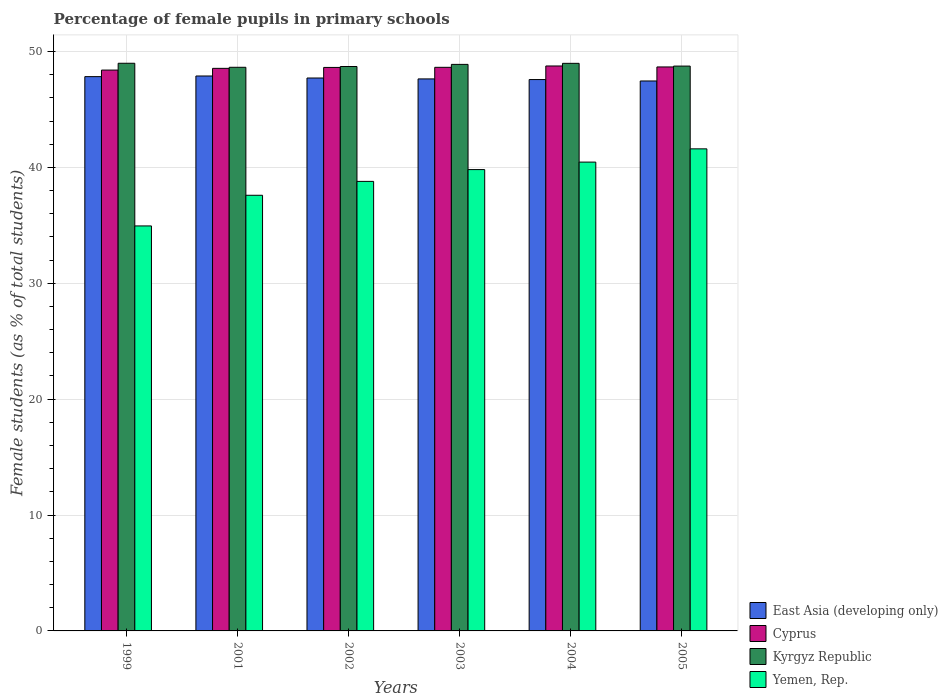How many different coloured bars are there?
Make the answer very short. 4. How many groups of bars are there?
Your answer should be compact. 6. How many bars are there on the 6th tick from the left?
Your answer should be very brief. 4. How many bars are there on the 2nd tick from the right?
Give a very brief answer. 4. What is the label of the 1st group of bars from the left?
Make the answer very short. 1999. What is the percentage of female pupils in primary schools in Yemen, Rep. in 2004?
Provide a succinct answer. 40.45. Across all years, what is the maximum percentage of female pupils in primary schools in Yemen, Rep.?
Provide a succinct answer. 41.6. Across all years, what is the minimum percentage of female pupils in primary schools in Cyprus?
Make the answer very short. 48.4. In which year was the percentage of female pupils in primary schools in Cyprus maximum?
Your answer should be very brief. 2004. In which year was the percentage of female pupils in primary schools in East Asia (developing only) minimum?
Provide a short and direct response. 2005. What is the total percentage of female pupils in primary schools in Cyprus in the graph?
Make the answer very short. 291.62. What is the difference between the percentage of female pupils in primary schools in Yemen, Rep. in 1999 and that in 2005?
Ensure brevity in your answer.  -6.65. What is the difference between the percentage of female pupils in primary schools in Yemen, Rep. in 2003 and the percentage of female pupils in primary schools in East Asia (developing only) in 1999?
Make the answer very short. -8.02. What is the average percentage of female pupils in primary schools in East Asia (developing only) per year?
Your answer should be compact. 47.68. In the year 2003, what is the difference between the percentage of female pupils in primary schools in Cyprus and percentage of female pupils in primary schools in Yemen, Rep.?
Give a very brief answer. 8.82. What is the ratio of the percentage of female pupils in primary schools in Kyrgyz Republic in 2003 to that in 2004?
Give a very brief answer. 1. Is the percentage of female pupils in primary schools in East Asia (developing only) in 1999 less than that in 2003?
Provide a short and direct response. No. What is the difference between the highest and the second highest percentage of female pupils in primary schools in East Asia (developing only)?
Your answer should be compact. 0.05. What is the difference between the highest and the lowest percentage of female pupils in primary schools in East Asia (developing only)?
Your answer should be very brief. 0.43. In how many years, is the percentage of female pupils in primary schools in Cyprus greater than the average percentage of female pupils in primary schools in Cyprus taken over all years?
Offer a very short reply. 4. Is the sum of the percentage of female pupils in primary schools in Kyrgyz Republic in 1999 and 2003 greater than the maximum percentage of female pupils in primary schools in Cyprus across all years?
Keep it short and to the point. Yes. What does the 1st bar from the left in 1999 represents?
Keep it short and to the point. East Asia (developing only). What does the 4th bar from the right in 2003 represents?
Provide a short and direct response. East Asia (developing only). Is it the case that in every year, the sum of the percentage of female pupils in primary schools in East Asia (developing only) and percentage of female pupils in primary schools in Yemen, Rep. is greater than the percentage of female pupils in primary schools in Cyprus?
Your response must be concise. Yes. What is the difference between two consecutive major ticks on the Y-axis?
Give a very brief answer. 10. How many legend labels are there?
Your answer should be compact. 4. How are the legend labels stacked?
Make the answer very short. Vertical. What is the title of the graph?
Offer a terse response. Percentage of female pupils in primary schools. Does "Niger" appear as one of the legend labels in the graph?
Offer a terse response. No. What is the label or title of the Y-axis?
Provide a succinct answer. Female students (as % of total students). What is the Female students (as % of total students) in East Asia (developing only) in 1999?
Provide a succinct answer. 47.83. What is the Female students (as % of total students) of Cyprus in 1999?
Your answer should be very brief. 48.4. What is the Female students (as % of total students) of Kyrgyz Republic in 1999?
Offer a very short reply. 48.98. What is the Female students (as % of total students) in Yemen, Rep. in 1999?
Your answer should be very brief. 34.95. What is the Female students (as % of total students) in East Asia (developing only) in 2001?
Ensure brevity in your answer.  47.89. What is the Female students (as % of total students) in Cyprus in 2001?
Your response must be concise. 48.55. What is the Female students (as % of total students) of Kyrgyz Republic in 2001?
Offer a very short reply. 48.64. What is the Female students (as % of total students) in Yemen, Rep. in 2001?
Offer a terse response. 37.59. What is the Female students (as % of total students) in East Asia (developing only) in 2002?
Your answer should be very brief. 47.71. What is the Female students (as % of total students) of Cyprus in 2002?
Give a very brief answer. 48.62. What is the Female students (as % of total students) of Kyrgyz Republic in 2002?
Give a very brief answer. 48.7. What is the Female students (as % of total students) of Yemen, Rep. in 2002?
Make the answer very short. 38.79. What is the Female students (as % of total students) in East Asia (developing only) in 2003?
Offer a terse response. 47.63. What is the Female students (as % of total students) of Cyprus in 2003?
Provide a short and direct response. 48.63. What is the Female students (as % of total students) of Kyrgyz Republic in 2003?
Your answer should be compact. 48.89. What is the Female students (as % of total students) of Yemen, Rep. in 2003?
Give a very brief answer. 39.81. What is the Female students (as % of total students) in East Asia (developing only) in 2004?
Make the answer very short. 47.58. What is the Female students (as % of total students) in Cyprus in 2004?
Provide a short and direct response. 48.75. What is the Female students (as % of total students) in Kyrgyz Republic in 2004?
Provide a succinct answer. 48.98. What is the Female students (as % of total students) of Yemen, Rep. in 2004?
Provide a succinct answer. 40.45. What is the Female students (as % of total students) in East Asia (developing only) in 2005?
Your response must be concise. 47.46. What is the Female students (as % of total students) in Cyprus in 2005?
Offer a very short reply. 48.67. What is the Female students (as % of total students) of Kyrgyz Republic in 2005?
Your answer should be compact. 48.74. What is the Female students (as % of total students) of Yemen, Rep. in 2005?
Your answer should be compact. 41.6. Across all years, what is the maximum Female students (as % of total students) of East Asia (developing only)?
Your response must be concise. 47.89. Across all years, what is the maximum Female students (as % of total students) in Cyprus?
Provide a succinct answer. 48.75. Across all years, what is the maximum Female students (as % of total students) in Kyrgyz Republic?
Offer a terse response. 48.98. Across all years, what is the maximum Female students (as % of total students) in Yemen, Rep.?
Give a very brief answer. 41.6. Across all years, what is the minimum Female students (as % of total students) of East Asia (developing only)?
Make the answer very short. 47.46. Across all years, what is the minimum Female students (as % of total students) of Cyprus?
Provide a short and direct response. 48.4. Across all years, what is the minimum Female students (as % of total students) of Kyrgyz Republic?
Your response must be concise. 48.64. Across all years, what is the minimum Female students (as % of total students) of Yemen, Rep.?
Your response must be concise. 34.95. What is the total Female students (as % of total students) in East Asia (developing only) in the graph?
Your answer should be compact. 286.1. What is the total Female students (as % of total students) in Cyprus in the graph?
Give a very brief answer. 291.62. What is the total Female students (as % of total students) of Kyrgyz Republic in the graph?
Give a very brief answer. 292.93. What is the total Female students (as % of total students) of Yemen, Rep. in the graph?
Provide a short and direct response. 233.2. What is the difference between the Female students (as % of total students) in East Asia (developing only) in 1999 and that in 2001?
Offer a very short reply. -0.05. What is the difference between the Female students (as % of total students) in Cyprus in 1999 and that in 2001?
Give a very brief answer. -0.15. What is the difference between the Female students (as % of total students) in Kyrgyz Republic in 1999 and that in 2001?
Your response must be concise. 0.35. What is the difference between the Female students (as % of total students) in Yemen, Rep. in 1999 and that in 2001?
Ensure brevity in your answer.  -2.65. What is the difference between the Female students (as % of total students) of East Asia (developing only) in 1999 and that in 2002?
Give a very brief answer. 0.12. What is the difference between the Female students (as % of total students) in Cyprus in 1999 and that in 2002?
Provide a short and direct response. -0.23. What is the difference between the Female students (as % of total students) of Kyrgyz Republic in 1999 and that in 2002?
Ensure brevity in your answer.  0.28. What is the difference between the Female students (as % of total students) of Yemen, Rep. in 1999 and that in 2002?
Make the answer very short. -3.84. What is the difference between the Female students (as % of total students) of East Asia (developing only) in 1999 and that in 2003?
Offer a very short reply. 0.2. What is the difference between the Female students (as % of total students) of Cyprus in 1999 and that in 2003?
Provide a succinct answer. -0.24. What is the difference between the Female students (as % of total students) of Kyrgyz Republic in 1999 and that in 2003?
Your answer should be compact. 0.1. What is the difference between the Female students (as % of total students) in Yemen, Rep. in 1999 and that in 2003?
Make the answer very short. -4.86. What is the difference between the Female students (as % of total students) in East Asia (developing only) in 1999 and that in 2004?
Offer a very short reply. 0.25. What is the difference between the Female students (as % of total students) in Cyprus in 1999 and that in 2004?
Give a very brief answer. -0.35. What is the difference between the Female students (as % of total students) in Kyrgyz Republic in 1999 and that in 2004?
Provide a short and direct response. 0.01. What is the difference between the Female students (as % of total students) in Yemen, Rep. in 1999 and that in 2004?
Your response must be concise. -5.51. What is the difference between the Female students (as % of total students) of East Asia (developing only) in 1999 and that in 2005?
Keep it short and to the point. 0.38. What is the difference between the Female students (as % of total students) of Cyprus in 1999 and that in 2005?
Ensure brevity in your answer.  -0.27. What is the difference between the Female students (as % of total students) in Kyrgyz Republic in 1999 and that in 2005?
Provide a succinct answer. 0.24. What is the difference between the Female students (as % of total students) in Yemen, Rep. in 1999 and that in 2005?
Offer a very short reply. -6.65. What is the difference between the Female students (as % of total students) of East Asia (developing only) in 2001 and that in 2002?
Your answer should be compact. 0.17. What is the difference between the Female students (as % of total students) of Cyprus in 2001 and that in 2002?
Offer a very short reply. -0.08. What is the difference between the Female students (as % of total students) in Kyrgyz Republic in 2001 and that in 2002?
Make the answer very short. -0.07. What is the difference between the Female students (as % of total students) in Yemen, Rep. in 2001 and that in 2002?
Provide a succinct answer. -1.2. What is the difference between the Female students (as % of total students) in East Asia (developing only) in 2001 and that in 2003?
Ensure brevity in your answer.  0.25. What is the difference between the Female students (as % of total students) in Cyprus in 2001 and that in 2003?
Keep it short and to the point. -0.09. What is the difference between the Female students (as % of total students) in Kyrgyz Republic in 2001 and that in 2003?
Keep it short and to the point. -0.25. What is the difference between the Female students (as % of total students) of Yemen, Rep. in 2001 and that in 2003?
Keep it short and to the point. -2.22. What is the difference between the Female students (as % of total students) in East Asia (developing only) in 2001 and that in 2004?
Your answer should be very brief. 0.31. What is the difference between the Female students (as % of total students) of Cyprus in 2001 and that in 2004?
Provide a succinct answer. -0.2. What is the difference between the Female students (as % of total students) in Kyrgyz Republic in 2001 and that in 2004?
Give a very brief answer. -0.34. What is the difference between the Female students (as % of total students) of Yemen, Rep. in 2001 and that in 2004?
Provide a succinct answer. -2.86. What is the difference between the Female students (as % of total students) of East Asia (developing only) in 2001 and that in 2005?
Provide a short and direct response. 0.43. What is the difference between the Female students (as % of total students) of Cyprus in 2001 and that in 2005?
Make the answer very short. -0.12. What is the difference between the Female students (as % of total students) in Kyrgyz Republic in 2001 and that in 2005?
Your answer should be very brief. -0.1. What is the difference between the Female students (as % of total students) of Yemen, Rep. in 2001 and that in 2005?
Give a very brief answer. -4.01. What is the difference between the Female students (as % of total students) in East Asia (developing only) in 2002 and that in 2003?
Your answer should be very brief. 0.08. What is the difference between the Female students (as % of total students) of Cyprus in 2002 and that in 2003?
Your response must be concise. -0.01. What is the difference between the Female students (as % of total students) of Kyrgyz Republic in 2002 and that in 2003?
Offer a terse response. -0.18. What is the difference between the Female students (as % of total students) of Yemen, Rep. in 2002 and that in 2003?
Provide a succinct answer. -1.02. What is the difference between the Female students (as % of total students) of East Asia (developing only) in 2002 and that in 2004?
Make the answer very short. 0.13. What is the difference between the Female students (as % of total students) of Cyprus in 2002 and that in 2004?
Your response must be concise. -0.13. What is the difference between the Female students (as % of total students) in Kyrgyz Republic in 2002 and that in 2004?
Provide a short and direct response. -0.27. What is the difference between the Female students (as % of total students) in Yemen, Rep. in 2002 and that in 2004?
Offer a terse response. -1.66. What is the difference between the Female students (as % of total students) of East Asia (developing only) in 2002 and that in 2005?
Keep it short and to the point. 0.26. What is the difference between the Female students (as % of total students) of Cyprus in 2002 and that in 2005?
Keep it short and to the point. -0.04. What is the difference between the Female students (as % of total students) in Kyrgyz Republic in 2002 and that in 2005?
Make the answer very short. -0.04. What is the difference between the Female students (as % of total students) of Yemen, Rep. in 2002 and that in 2005?
Give a very brief answer. -2.81. What is the difference between the Female students (as % of total students) of East Asia (developing only) in 2003 and that in 2004?
Ensure brevity in your answer.  0.06. What is the difference between the Female students (as % of total students) of Cyprus in 2003 and that in 2004?
Give a very brief answer. -0.12. What is the difference between the Female students (as % of total students) in Kyrgyz Republic in 2003 and that in 2004?
Ensure brevity in your answer.  -0.09. What is the difference between the Female students (as % of total students) in Yemen, Rep. in 2003 and that in 2004?
Your answer should be compact. -0.64. What is the difference between the Female students (as % of total students) of East Asia (developing only) in 2003 and that in 2005?
Make the answer very short. 0.18. What is the difference between the Female students (as % of total students) in Cyprus in 2003 and that in 2005?
Offer a very short reply. -0.03. What is the difference between the Female students (as % of total students) in Kyrgyz Republic in 2003 and that in 2005?
Provide a short and direct response. 0.15. What is the difference between the Female students (as % of total students) in Yemen, Rep. in 2003 and that in 2005?
Provide a succinct answer. -1.79. What is the difference between the Female students (as % of total students) in East Asia (developing only) in 2004 and that in 2005?
Keep it short and to the point. 0.12. What is the difference between the Female students (as % of total students) in Cyprus in 2004 and that in 2005?
Offer a terse response. 0.08. What is the difference between the Female students (as % of total students) in Kyrgyz Republic in 2004 and that in 2005?
Provide a succinct answer. 0.24. What is the difference between the Female students (as % of total students) of Yemen, Rep. in 2004 and that in 2005?
Keep it short and to the point. -1.14. What is the difference between the Female students (as % of total students) of East Asia (developing only) in 1999 and the Female students (as % of total students) of Cyprus in 2001?
Provide a succinct answer. -0.71. What is the difference between the Female students (as % of total students) of East Asia (developing only) in 1999 and the Female students (as % of total students) of Kyrgyz Republic in 2001?
Ensure brevity in your answer.  -0.81. What is the difference between the Female students (as % of total students) of East Asia (developing only) in 1999 and the Female students (as % of total students) of Yemen, Rep. in 2001?
Your answer should be very brief. 10.24. What is the difference between the Female students (as % of total students) of Cyprus in 1999 and the Female students (as % of total students) of Kyrgyz Republic in 2001?
Provide a short and direct response. -0.24. What is the difference between the Female students (as % of total students) in Cyprus in 1999 and the Female students (as % of total students) in Yemen, Rep. in 2001?
Your answer should be compact. 10.8. What is the difference between the Female students (as % of total students) in Kyrgyz Republic in 1999 and the Female students (as % of total students) in Yemen, Rep. in 2001?
Your answer should be very brief. 11.39. What is the difference between the Female students (as % of total students) of East Asia (developing only) in 1999 and the Female students (as % of total students) of Cyprus in 2002?
Provide a short and direct response. -0.79. What is the difference between the Female students (as % of total students) in East Asia (developing only) in 1999 and the Female students (as % of total students) in Kyrgyz Republic in 2002?
Provide a short and direct response. -0.87. What is the difference between the Female students (as % of total students) of East Asia (developing only) in 1999 and the Female students (as % of total students) of Yemen, Rep. in 2002?
Your answer should be very brief. 9.04. What is the difference between the Female students (as % of total students) in Cyprus in 1999 and the Female students (as % of total students) in Kyrgyz Republic in 2002?
Ensure brevity in your answer.  -0.31. What is the difference between the Female students (as % of total students) in Cyprus in 1999 and the Female students (as % of total students) in Yemen, Rep. in 2002?
Provide a succinct answer. 9.6. What is the difference between the Female students (as % of total students) in Kyrgyz Republic in 1999 and the Female students (as % of total students) in Yemen, Rep. in 2002?
Give a very brief answer. 10.19. What is the difference between the Female students (as % of total students) in East Asia (developing only) in 1999 and the Female students (as % of total students) in Cyprus in 2003?
Your answer should be compact. -0.8. What is the difference between the Female students (as % of total students) in East Asia (developing only) in 1999 and the Female students (as % of total students) in Kyrgyz Republic in 2003?
Give a very brief answer. -1.06. What is the difference between the Female students (as % of total students) of East Asia (developing only) in 1999 and the Female students (as % of total students) of Yemen, Rep. in 2003?
Your response must be concise. 8.02. What is the difference between the Female students (as % of total students) of Cyprus in 1999 and the Female students (as % of total students) of Kyrgyz Republic in 2003?
Your answer should be compact. -0.49. What is the difference between the Female students (as % of total students) of Cyprus in 1999 and the Female students (as % of total students) of Yemen, Rep. in 2003?
Make the answer very short. 8.59. What is the difference between the Female students (as % of total students) in Kyrgyz Republic in 1999 and the Female students (as % of total students) in Yemen, Rep. in 2003?
Your response must be concise. 9.17. What is the difference between the Female students (as % of total students) in East Asia (developing only) in 1999 and the Female students (as % of total students) in Cyprus in 2004?
Provide a short and direct response. -0.92. What is the difference between the Female students (as % of total students) of East Asia (developing only) in 1999 and the Female students (as % of total students) of Kyrgyz Republic in 2004?
Offer a terse response. -1.15. What is the difference between the Female students (as % of total students) of East Asia (developing only) in 1999 and the Female students (as % of total students) of Yemen, Rep. in 2004?
Ensure brevity in your answer.  7.38. What is the difference between the Female students (as % of total students) of Cyprus in 1999 and the Female students (as % of total students) of Kyrgyz Republic in 2004?
Ensure brevity in your answer.  -0.58. What is the difference between the Female students (as % of total students) of Cyprus in 1999 and the Female students (as % of total students) of Yemen, Rep. in 2004?
Ensure brevity in your answer.  7.94. What is the difference between the Female students (as % of total students) in Kyrgyz Republic in 1999 and the Female students (as % of total students) in Yemen, Rep. in 2004?
Give a very brief answer. 8.53. What is the difference between the Female students (as % of total students) of East Asia (developing only) in 1999 and the Female students (as % of total students) of Cyprus in 2005?
Give a very brief answer. -0.84. What is the difference between the Female students (as % of total students) in East Asia (developing only) in 1999 and the Female students (as % of total students) in Kyrgyz Republic in 2005?
Ensure brevity in your answer.  -0.91. What is the difference between the Female students (as % of total students) of East Asia (developing only) in 1999 and the Female students (as % of total students) of Yemen, Rep. in 2005?
Your answer should be compact. 6.23. What is the difference between the Female students (as % of total students) of Cyprus in 1999 and the Female students (as % of total students) of Kyrgyz Republic in 2005?
Give a very brief answer. -0.34. What is the difference between the Female students (as % of total students) of Cyprus in 1999 and the Female students (as % of total students) of Yemen, Rep. in 2005?
Provide a succinct answer. 6.8. What is the difference between the Female students (as % of total students) in Kyrgyz Republic in 1999 and the Female students (as % of total students) in Yemen, Rep. in 2005?
Offer a terse response. 7.39. What is the difference between the Female students (as % of total students) in East Asia (developing only) in 2001 and the Female students (as % of total students) in Cyprus in 2002?
Your answer should be very brief. -0.74. What is the difference between the Female students (as % of total students) in East Asia (developing only) in 2001 and the Female students (as % of total students) in Kyrgyz Republic in 2002?
Give a very brief answer. -0.82. What is the difference between the Female students (as % of total students) in East Asia (developing only) in 2001 and the Female students (as % of total students) in Yemen, Rep. in 2002?
Ensure brevity in your answer.  9.09. What is the difference between the Female students (as % of total students) of Cyprus in 2001 and the Female students (as % of total students) of Kyrgyz Republic in 2002?
Provide a succinct answer. -0.16. What is the difference between the Female students (as % of total students) in Cyprus in 2001 and the Female students (as % of total students) in Yemen, Rep. in 2002?
Your answer should be compact. 9.75. What is the difference between the Female students (as % of total students) of Kyrgyz Republic in 2001 and the Female students (as % of total students) of Yemen, Rep. in 2002?
Your response must be concise. 9.84. What is the difference between the Female students (as % of total students) in East Asia (developing only) in 2001 and the Female students (as % of total students) in Cyprus in 2003?
Offer a terse response. -0.75. What is the difference between the Female students (as % of total students) of East Asia (developing only) in 2001 and the Female students (as % of total students) of Kyrgyz Republic in 2003?
Your answer should be very brief. -1. What is the difference between the Female students (as % of total students) of East Asia (developing only) in 2001 and the Female students (as % of total students) of Yemen, Rep. in 2003?
Provide a short and direct response. 8.08. What is the difference between the Female students (as % of total students) of Cyprus in 2001 and the Female students (as % of total students) of Kyrgyz Republic in 2003?
Ensure brevity in your answer.  -0.34. What is the difference between the Female students (as % of total students) in Cyprus in 2001 and the Female students (as % of total students) in Yemen, Rep. in 2003?
Offer a very short reply. 8.74. What is the difference between the Female students (as % of total students) of Kyrgyz Republic in 2001 and the Female students (as % of total students) of Yemen, Rep. in 2003?
Provide a short and direct response. 8.83. What is the difference between the Female students (as % of total students) of East Asia (developing only) in 2001 and the Female students (as % of total students) of Cyprus in 2004?
Your answer should be very brief. -0.86. What is the difference between the Female students (as % of total students) in East Asia (developing only) in 2001 and the Female students (as % of total students) in Kyrgyz Republic in 2004?
Your answer should be compact. -1.09. What is the difference between the Female students (as % of total students) in East Asia (developing only) in 2001 and the Female students (as % of total students) in Yemen, Rep. in 2004?
Make the answer very short. 7.43. What is the difference between the Female students (as % of total students) in Cyprus in 2001 and the Female students (as % of total students) in Kyrgyz Republic in 2004?
Ensure brevity in your answer.  -0.43. What is the difference between the Female students (as % of total students) in Cyprus in 2001 and the Female students (as % of total students) in Yemen, Rep. in 2004?
Make the answer very short. 8.09. What is the difference between the Female students (as % of total students) of Kyrgyz Republic in 2001 and the Female students (as % of total students) of Yemen, Rep. in 2004?
Your response must be concise. 8.18. What is the difference between the Female students (as % of total students) in East Asia (developing only) in 2001 and the Female students (as % of total students) in Cyprus in 2005?
Ensure brevity in your answer.  -0.78. What is the difference between the Female students (as % of total students) of East Asia (developing only) in 2001 and the Female students (as % of total students) of Kyrgyz Republic in 2005?
Give a very brief answer. -0.86. What is the difference between the Female students (as % of total students) in East Asia (developing only) in 2001 and the Female students (as % of total students) in Yemen, Rep. in 2005?
Your response must be concise. 6.29. What is the difference between the Female students (as % of total students) in Cyprus in 2001 and the Female students (as % of total students) in Kyrgyz Republic in 2005?
Your answer should be very brief. -0.2. What is the difference between the Female students (as % of total students) of Cyprus in 2001 and the Female students (as % of total students) of Yemen, Rep. in 2005?
Your response must be concise. 6.95. What is the difference between the Female students (as % of total students) in Kyrgyz Republic in 2001 and the Female students (as % of total students) in Yemen, Rep. in 2005?
Provide a succinct answer. 7.04. What is the difference between the Female students (as % of total students) in East Asia (developing only) in 2002 and the Female students (as % of total students) in Cyprus in 2003?
Provide a succinct answer. -0.92. What is the difference between the Female students (as % of total students) in East Asia (developing only) in 2002 and the Female students (as % of total students) in Kyrgyz Republic in 2003?
Ensure brevity in your answer.  -1.18. What is the difference between the Female students (as % of total students) in East Asia (developing only) in 2002 and the Female students (as % of total students) in Yemen, Rep. in 2003?
Your response must be concise. 7.9. What is the difference between the Female students (as % of total students) in Cyprus in 2002 and the Female students (as % of total students) in Kyrgyz Republic in 2003?
Your answer should be compact. -0.26. What is the difference between the Female students (as % of total students) in Cyprus in 2002 and the Female students (as % of total students) in Yemen, Rep. in 2003?
Your answer should be compact. 8.81. What is the difference between the Female students (as % of total students) of Kyrgyz Republic in 2002 and the Female students (as % of total students) of Yemen, Rep. in 2003?
Make the answer very short. 8.89. What is the difference between the Female students (as % of total students) of East Asia (developing only) in 2002 and the Female students (as % of total students) of Cyprus in 2004?
Make the answer very short. -1.04. What is the difference between the Female students (as % of total students) in East Asia (developing only) in 2002 and the Female students (as % of total students) in Kyrgyz Republic in 2004?
Offer a very short reply. -1.27. What is the difference between the Female students (as % of total students) in East Asia (developing only) in 2002 and the Female students (as % of total students) in Yemen, Rep. in 2004?
Provide a short and direct response. 7.26. What is the difference between the Female students (as % of total students) in Cyprus in 2002 and the Female students (as % of total students) in Kyrgyz Republic in 2004?
Give a very brief answer. -0.35. What is the difference between the Female students (as % of total students) in Cyprus in 2002 and the Female students (as % of total students) in Yemen, Rep. in 2004?
Offer a very short reply. 8.17. What is the difference between the Female students (as % of total students) in Kyrgyz Republic in 2002 and the Female students (as % of total students) in Yemen, Rep. in 2004?
Provide a succinct answer. 8.25. What is the difference between the Female students (as % of total students) of East Asia (developing only) in 2002 and the Female students (as % of total students) of Cyprus in 2005?
Ensure brevity in your answer.  -0.96. What is the difference between the Female students (as % of total students) of East Asia (developing only) in 2002 and the Female students (as % of total students) of Kyrgyz Republic in 2005?
Offer a terse response. -1.03. What is the difference between the Female students (as % of total students) in East Asia (developing only) in 2002 and the Female students (as % of total students) in Yemen, Rep. in 2005?
Your response must be concise. 6.11. What is the difference between the Female students (as % of total students) in Cyprus in 2002 and the Female students (as % of total students) in Kyrgyz Republic in 2005?
Provide a succinct answer. -0.12. What is the difference between the Female students (as % of total students) in Cyprus in 2002 and the Female students (as % of total students) in Yemen, Rep. in 2005?
Ensure brevity in your answer.  7.03. What is the difference between the Female students (as % of total students) of Kyrgyz Republic in 2002 and the Female students (as % of total students) of Yemen, Rep. in 2005?
Your response must be concise. 7.11. What is the difference between the Female students (as % of total students) of East Asia (developing only) in 2003 and the Female students (as % of total students) of Cyprus in 2004?
Make the answer very short. -1.12. What is the difference between the Female students (as % of total students) in East Asia (developing only) in 2003 and the Female students (as % of total students) in Kyrgyz Republic in 2004?
Ensure brevity in your answer.  -1.34. What is the difference between the Female students (as % of total students) in East Asia (developing only) in 2003 and the Female students (as % of total students) in Yemen, Rep. in 2004?
Make the answer very short. 7.18. What is the difference between the Female students (as % of total students) in Cyprus in 2003 and the Female students (as % of total students) in Kyrgyz Republic in 2004?
Keep it short and to the point. -0.34. What is the difference between the Female students (as % of total students) of Cyprus in 2003 and the Female students (as % of total students) of Yemen, Rep. in 2004?
Keep it short and to the point. 8.18. What is the difference between the Female students (as % of total students) of Kyrgyz Republic in 2003 and the Female students (as % of total students) of Yemen, Rep. in 2004?
Provide a succinct answer. 8.43. What is the difference between the Female students (as % of total students) in East Asia (developing only) in 2003 and the Female students (as % of total students) in Cyprus in 2005?
Give a very brief answer. -1.03. What is the difference between the Female students (as % of total students) in East Asia (developing only) in 2003 and the Female students (as % of total students) in Kyrgyz Republic in 2005?
Give a very brief answer. -1.11. What is the difference between the Female students (as % of total students) in East Asia (developing only) in 2003 and the Female students (as % of total students) in Yemen, Rep. in 2005?
Ensure brevity in your answer.  6.03. What is the difference between the Female students (as % of total students) in Cyprus in 2003 and the Female students (as % of total students) in Kyrgyz Republic in 2005?
Your answer should be very brief. -0.11. What is the difference between the Female students (as % of total students) in Cyprus in 2003 and the Female students (as % of total students) in Yemen, Rep. in 2005?
Keep it short and to the point. 7.03. What is the difference between the Female students (as % of total students) in Kyrgyz Republic in 2003 and the Female students (as % of total students) in Yemen, Rep. in 2005?
Offer a terse response. 7.29. What is the difference between the Female students (as % of total students) of East Asia (developing only) in 2004 and the Female students (as % of total students) of Cyprus in 2005?
Keep it short and to the point. -1.09. What is the difference between the Female students (as % of total students) of East Asia (developing only) in 2004 and the Female students (as % of total students) of Kyrgyz Republic in 2005?
Ensure brevity in your answer.  -1.16. What is the difference between the Female students (as % of total students) of East Asia (developing only) in 2004 and the Female students (as % of total students) of Yemen, Rep. in 2005?
Provide a succinct answer. 5.98. What is the difference between the Female students (as % of total students) in Cyprus in 2004 and the Female students (as % of total students) in Kyrgyz Republic in 2005?
Give a very brief answer. 0.01. What is the difference between the Female students (as % of total students) in Cyprus in 2004 and the Female students (as % of total students) in Yemen, Rep. in 2005?
Your answer should be very brief. 7.15. What is the difference between the Female students (as % of total students) of Kyrgyz Republic in 2004 and the Female students (as % of total students) of Yemen, Rep. in 2005?
Provide a short and direct response. 7.38. What is the average Female students (as % of total students) of East Asia (developing only) per year?
Provide a succinct answer. 47.68. What is the average Female students (as % of total students) in Cyprus per year?
Offer a terse response. 48.6. What is the average Female students (as % of total students) of Kyrgyz Republic per year?
Give a very brief answer. 48.82. What is the average Female students (as % of total students) of Yemen, Rep. per year?
Your answer should be compact. 38.87. In the year 1999, what is the difference between the Female students (as % of total students) of East Asia (developing only) and Female students (as % of total students) of Cyprus?
Offer a very short reply. -0.57. In the year 1999, what is the difference between the Female students (as % of total students) of East Asia (developing only) and Female students (as % of total students) of Kyrgyz Republic?
Your answer should be very brief. -1.15. In the year 1999, what is the difference between the Female students (as % of total students) of East Asia (developing only) and Female students (as % of total students) of Yemen, Rep.?
Give a very brief answer. 12.88. In the year 1999, what is the difference between the Female students (as % of total students) of Cyprus and Female students (as % of total students) of Kyrgyz Republic?
Provide a short and direct response. -0.59. In the year 1999, what is the difference between the Female students (as % of total students) in Cyprus and Female students (as % of total students) in Yemen, Rep.?
Offer a terse response. 13.45. In the year 1999, what is the difference between the Female students (as % of total students) in Kyrgyz Republic and Female students (as % of total students) in Yemen, Rep.?
Offer a terse response. 14.04. In the year 2001, what is the difference between the Female students (as % of total students) in East Asia (developing only) and Female students (as % of total students) in Cyprus?
Offer a terse response. -0.66. In the year 2001, what is the difference between the Female students (as % of total students) in East Asia (developing only) and Female students (as % of total students) in Kyrgyz Republic?
Ensure brevity in your answer.  -0.75. In the year 2001, what is the difference between the Female students (as % of total students) in East Asia (developing only) and Female students (as % of total students) in Yemen, Rep.?
Provide a succinct answer. 10.29. In the year 2001, what is the difference between the Female students (as % of total students) in Cyprus and Female students (as % of total students) in Kyrgyz Republic?
Your answer should be compact. -0.09. In the year 2001, what is the difference between the Female students (as % of total students) of Cyprus and Female students (as % of total students) of Yemen, Rep.?
Your response must be concise. 10.95. In the year 2001, what is the difference between the Female students (as % of total students) in Kyrgyz Republic and Female students (as % of total students) in Yemen, Rep.?
Keep it short and to the point. 11.04. In the year 2002, what is the difference between the Female students (as % of total students) of East Asia (developing only) and Female students (as % of total students) of Cyprus?
Provide a short and direct response. -0.91. In the year 2002, what is the difference between the Female students (as % of total students) of East Asia (developing only) and Female students (as % of total students) of Kyrgyz Republic?
Offer a terse response. -0.99. In the year 2002, what is the difference between the Female students (as % of total students) in East Asia (developing only) and Female students (as % of total students) in Yemen, Rep.?
Provide a short and direct response. 8.92. In the year 2002, what is the difference between the Female students (as % of total students) of Cyprus and Female students (as % of total students) of Kyrgyz Republic?
Your answer should be very brief. -0.08. In the year 2002, what is the difference between the Female students (as % of total students) of Cyprus and Female students (as % of total students) of Yemen, Rep.?
Offer a terse response. 9.83. In the year 2002, what is the difference between the Female students (as % of total students) of Kyrgyz Republic and Female students (as % of total students) of Yemen, Rep.?
Provide a short and direct response. 9.91. In the year 2003, what is the difference between the Female students (as % of total students) in East Asia (developing only) and Female students (as % of total students) in Cyprus?
Keep it short and to the point. -1. In the year 2003, what is the difference between the Female students (as % of total students) of East Asia (developing only) and Female students (as % of total students) of Kyrgyz Republic?
Keep it short and to the point. -1.25. In the year 2003, what is the difference between the Female students (as % of total students) in East Asia (developing only) and Female students (as % of total students) in Yemen, Rep.?
Make the answer very short. 7.82. In the year 2003, what is the difference between the Female students (as % of total students) of Cyprus and Female students (as % of total students) of Kyrgyz Republic?
Offer a very short reply. -0.25. In the year 2003, what is the difference between the Female students (as % of total students) in Cyprus and Female students (as % of total students) in Yemen, Rep.?
Provide a succinct answer. 8.82. In the year 2003, what is the difference between the Female students (as % of total students) of Kyrgyz Republic and Female students (as % of total students) of Yemen, Rep.?
Keep it short and to the point. 9.08. In the year 2004, what is the difference between the Female students (as % of total students) in East Asia (developing only) and Female students (as % of total students) in Cyprus?
Offer a terse response. -1.17. In the year 2004, what is the difference between the Female students (as % of total students) in East Asia (developing only) and Female students (as % of total students) in Kyrgyz Republic?
Offer a terse response. -1.4. In the year 2004, what is the difference between the Female students (as % of total students) of East Asia (developing only) and Female students (as % of total students) of Yemen, Rep.?
Make the answer very short. 7.12. In the year 2004, what is the difference between the Female students (as % of total students) of Cyprus and Female students (as % of total students) of Kyrgyz Republic?
Your answer should be very brief. -0.23. In the year 2004, what is the difference between the Female students (as % of total students) of Cyprus and Female students (as % of total students) of Yemen, Rep.?
Offer a terse response. 8.3. In the year 2004, what is the difference between the Female students (as % of total students) of Kyrgyz Republic and Female students (as % of total students) of Yemen, Rep.?
Provide a succinct answer. 8.52. In the year 2005, what is the difference between the Female students (as % of total students) of East Asia (developing only) and Female students (as % of total students) of Cyprus?
Your answer should be very brief. -1.21. In the year 2005, what is the difference between the Female students (as % of total students) in East Asia (developing only) and Female students (as % of total students) in Kyrgyz Republic?
Your answer should be very brief. -1.29. In the year 2005, what is the difference between the Female students (as % of total students) of East Asia (developing only) and Female students (as % of total students) of Yemen, Rep.?
Your answer should be very brief. 5.86. In the year 2005, what is the difference between the Female students (as % of total students) of Cyprus and Female students (as % of total students) of Kyrgyz Republic?
Ensure brevity in your answer.  -0.07. In the year 2005, what is the difference between the Female students (as % of total students) in Cyprus and Female students (as % of total students) in Yemen, Rep.?
Give a very brief answer. 7.07. In the year 2005, what is the difference between the Female students (as % of total students) in Kyrgyz Republic and Female students (as % of total students) in Yemen, Rep.?
Offer a terse response. 7.14. What is the ratio of the Female students (as % of total students) in Yemen, Rep. in 1999 to that in 2001?
Your answer should be compact. 0.93. What is the ratio of the Female students (as % of total students) in East Asia (developing only) in 1999 to that in 2002?
Offer a terse response. 1. What is the ratio of the Female students (as % of total students) in Cyprus in 1999 to that in 2002?
Give a very brief answer. 1. What is the ratio of the Female students (as % of total students) in Yemen, Rep. in 1999 to that in 2002?
Provide a succinct answer. 0.9. What is the ratio of the Female students (as % of total students) in East Asia (developing only) in 1999 to that in 2003?
Make the answer very short. 1. What is the ratio of the Female students (as % of total students) in Kyrgyz Republic in 1999 to that in 2003?
Offer a terse response. 1. What is the ratio of the Female students (as % of total students) of Yemen, Rep. in 1999 to that in 2003?
Your response must be concise. 0.88. What is the ratio of the Female students (as % of total students) of Cyprus in 1999 to that in 2004?
Your response must be concise. 0.99. What is the ratio of the Female students (as % of total students) of Yemen, Rep. in 1999 to that in 2004?
Offer a very short reply. 0.86. What is the ratio of the Female students (as % of total students) of East Asia (developing only) in 1999 to that in 2005?
Your response must be concise. 1.01. What is the ratio of the Female students (as % of total students) of Kyrgyz Republic in 1999 to that in 2005?
Your response must be concise. 1. What is the ratio of the Female students (as % of total students) in Yemen, Rep. in 1999 to that in 2005?
Ensure brevity in your answer.  0.84. What is the ratio of the Female students (as % of total students) in Kyrgyz Republic in 2001 to that in 2002?
Your answer should be very brief. 1. What is the ratio of the Female students (as % of total students) in Yemen, Rep. in 2001 to that in 2002?
Keep it short and to the point. 0.97. What is the ratio of the Female students (as % of total students) of East Asia (developing only) in 2001 to that in 2003?
Offer a very short reply. 1.01. What is the ratio of the Female students (as % of total students) in Cyprus in 2001 to that in 2003?
Provide a succinct answer. 1. What is the ratio of the Female students (as % of total students) of Yemen, Rep. in 2001 to that in 2003?
Provide a short and direct response. 0.94. What is the ratio of the Female students (as % of total students) in East Asia (developing only) in 2001 to that in 2004?
Provide a succinct answer. 1.01. What is the ratio of the Female students (as % of total students) in Kyrgyz Republic in 2001 to that in 2004?
Make the answer very short. 0.99. What is the ratio of the Female students (as % of total students) in Yemen, Rep. in 2001 to that in 2004?
Provide a short and direct response. 0.93. What is the ratio of the Female students (as % of total students) in East Asia (developing only) in 2001 to that in 2005?
Give a very brief answer. 1.01. What is the ratio of the Female students (as % of total students) of Cyprus in 2001 to that in 2005?
Your answer should be very brief. 1. What is the ratio of the Female students (as % of total students) of Yemen, Rep. in 2001 to that in 2005?
Your response must be concise. 0.9. What is the ratio of the Female students (as % of total students) of Kyrgyz Republic in 2002 to that in 2003?
Your answer should be compact. 1. What is the ratio of the Female students (as % of total students) of Yemen, Rep. in 2002 to that in 2003?
Provide a succinct answer. 0.97. What is the ratio of the Female students (as % of total students) of Cyprus in 2002 to that in 2004?
Keep it short and to the point. 1. What is the ratio of the Female students (as % of total students) in Yemen, Rep. in 2002 to that in 2004?
Ensure brevity in your answer.  0.96. What is the ratio of the Female students (as % of total students) of East Asia (developing only) in 2002 to that in 2005?
Keep it short and to the point. 1.01. What is the ratio of the Female students (as % of total students) of Cyprus in 2002 to that in 2005?
Provide a short and direct response. 1. What is the ratio of the Female students (as % of total students) in Kyrgyz Republic in 2002 to that in 2005?
Offer a terse response. 1. What is the ratio of the Female students (as % of total students) of Yemen, Rep. in 2002 to that in 2005?
Your response must be concise. 0.93. What is the ratio of the Female students (as % of total students) of Kyrgyz Republic in 2003 to that in 2004?
Provide a succinct answer. 1. What is the ratio of the Female students (as % of total students) in Yemen, Rep. in 2003 to that in 2004?
Your answer should be compact. 0.98. What is the ratio of the Female students (as % of total students) of Cyprus in 2003 to that in 2005?
Give a very brief answer. 1. What is the ratio of the Female students (as % of total students) in Yemen, Rep. in 2003 to that in 2005?
Keep it short and to the point. 0.96. What is the ratio of the Female students (as % of total students) in East Asia (developing only) in 2004 to that in 2005?
Your response must be concise. 1. What is the ratio of the Female students (as % of total students) of Cyprus in 2004 to that in 2005?
Your answer should be very brief. 1. What is the ratio of the Female students (as % of total students) in Yemen, Rep. in 2004 to that in 2005?
Offer a very short reply. 0.97. What is the difference between the highest and the second highest Female students (as % of total students) of East Asia (developing only)?
Ensure brevity in your answer.  0.05. What is the difference between the highest and the second highest Female students (as % of total students) of Cyprus?
Make the answer very short. 0.08. What is the difference between the highest and the second highest Female students (as % of total students) of Kyrgyz Republic?
Provide a succinct answer. 0.01. What is the difference between the highest and the second highest Female students (as % of total students) of Yemen, Rep.?
Give a very brief answer. 1.14. What is the difference between the highest and the lowest Female students (as % of total students) in East Asia (developing only)?
Give a very brief answer. 0.43. What is the difference between the highest and the lowest Female students (as % of total students) in Cyprus?
Give a very brief answer. 0.35. What is the difference between the highest and the lowest Female students (as % of total students) of Kyrgyz Republic?
Ensure brevity in your answer.  0.35. What is the difference between the highest and the lowest Female students (as % of total students) in Yemen, Rep.?
Provide a short and direct response. 6.65. 